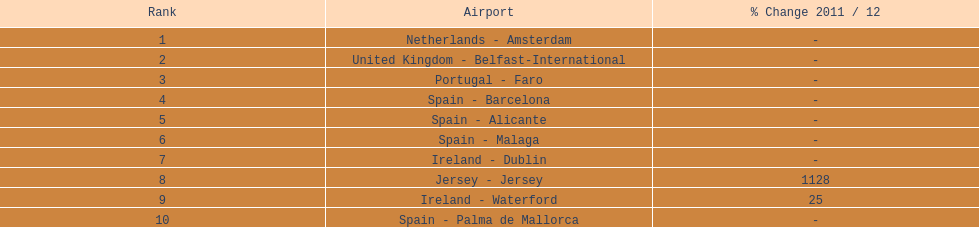What are all of the destinations out of the london southend airport? Netherlands - Amsterdam, United Kingdom - Belfast-International, Portugal - Faro, Spain - Barcelona, Spain - Alicante, Spain - Malaga, Ireland - Dublin, Jersey - Jersey, Ireland - Waterford, Spain - Palma de Mallorca. How many passengers has each destination handled? 105,349, 92,502, 71,676, 66,565, 64,090, 59,175, 35,524, 35,169, 31,907, 27,718. And of those, which airport handled the fewest passengers? Spain - Palma de Mallorca. 